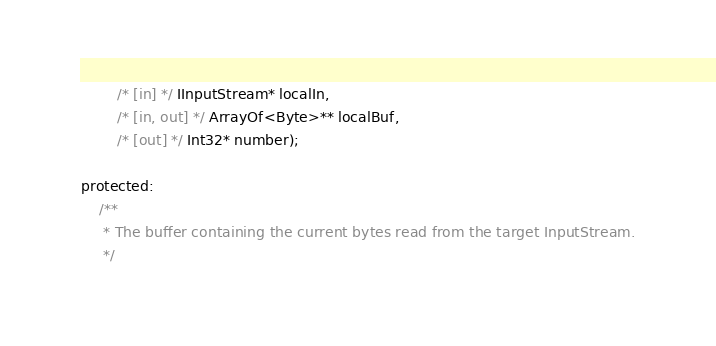Convert code to text. <code><loc_0><loc_0><loc_500><loc_500><_C_>        /* [in] */ IInputStream* localIn,
        /* [in, out] */ ArrayOf<Byte>** localBuf,
        /* [out] */ Int32* number);

protected:
    /**
     * The buffer containing the current bytes read from the target InputStream.
     */</code> 